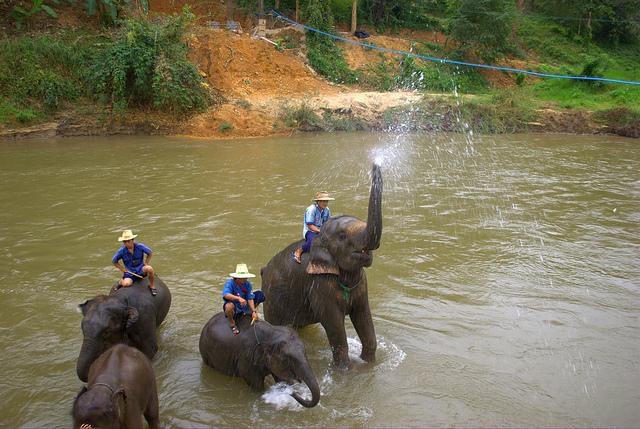What is the purpose of the blue rope?
Be succinct. Zipline. What is coming out of the elephants trunk?
Short answer required. Water. Why are the elephants in the water?
Concise answer only. For fun. 